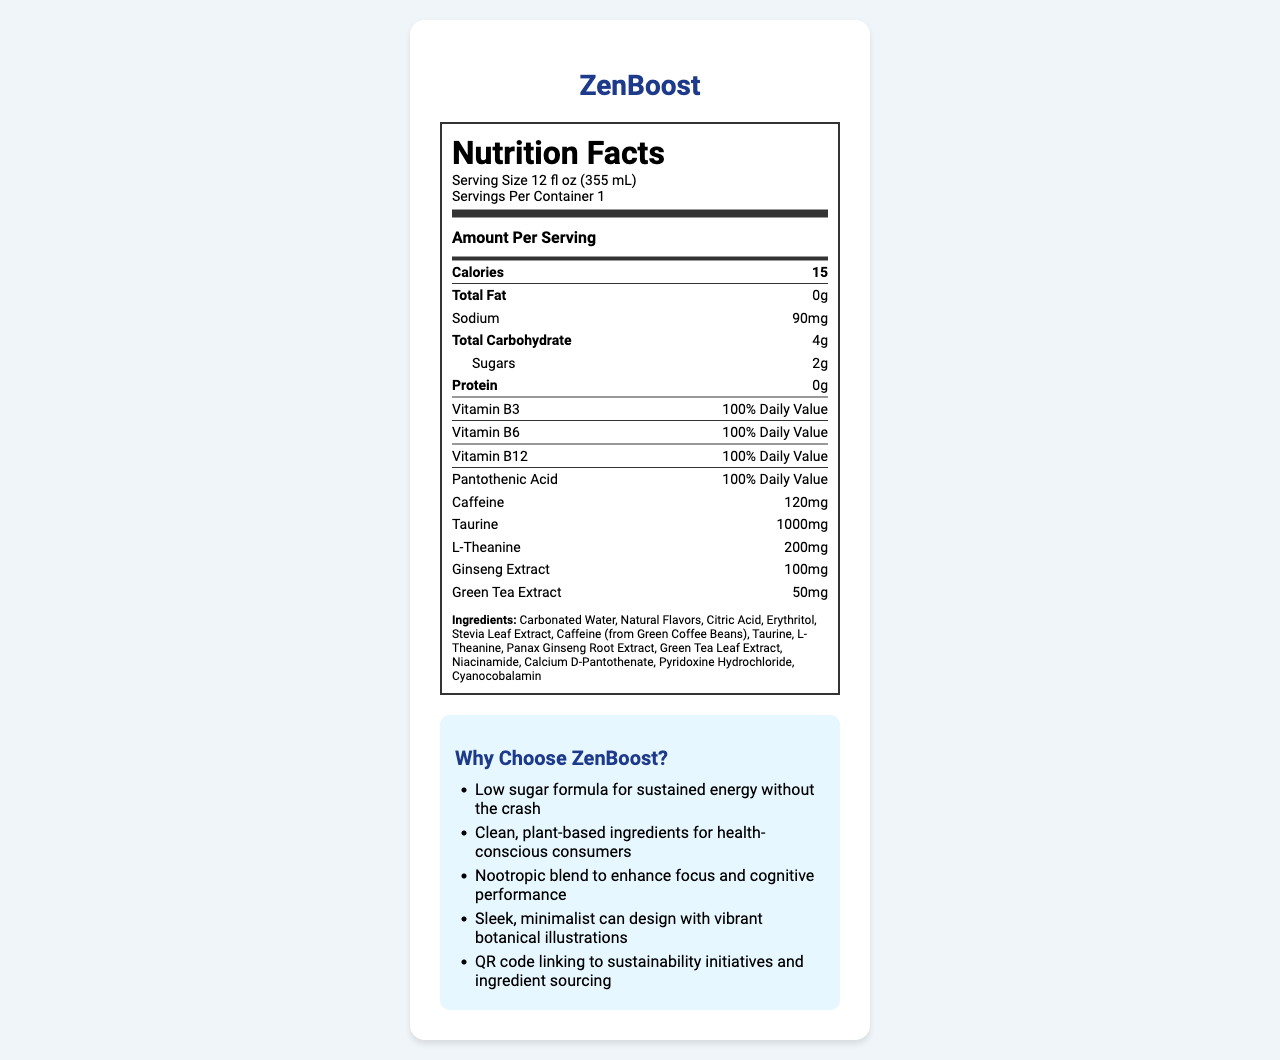What is the serving size of ZenBoost? The serving size is explicitly mentioned at the top of the nutrition facts label.
Answer: 12 fl oz (355 mL) How many calories are in one serving of ZenBoost? The calories per serving are listed in the "Amount Per Serving" section of the nutrition facts label.
Answer: 15 What is the total carbohydrate content in ZenBoost? The total carbohydrate content is specified under the nutrient rows in the nutrition facts label.
Answer: 4g How much caffeine does ZenBoost contain per serving? The caffeine content per serving is listed in the nutrient rows section.
Answer: 120mg Name two ingredients found in ZenBoost. The ingredients are listed towards the bottom section of the nutrition facts label.
Answer: Carbonated Water, Natural Flavors True or False: ZenBoost contains protein. The protein content is listed as 0g in the nutrition facts label.
Answer: False Which of the following vitamins does ZenBoost provide 100% of the Daily Value? A. Vitamin C B. Vitamin B6 C. Vitamin D D. Vitamin B12 Both Vitamin B6 and Vitamin B12 have 100% Daily Value as listed in the vitamin rows section of the nutrition facts label.
Answer: B, D Which distribution channel is mentioned for ZenBoost? A. Walmart B. Target C. Costco D. Sam's Club Target is listed as one of the distribution channels for ZenBoost.
Answer: B Give one marketing point for ZenBoost. One of the marketing points listed is the low sugar formula for sustained energy.
Answer: Low sugar formula for sustained energy without the crash Describe the main idea of the document. The document serves as an informative label detailing the nutritional content, special ingredients, and marketing messages of ZenBoost, targeting health-conscious young adults.
Answer: The document provides detailed nutrition facts, ingredients, and marketing points for ZenBoost, a low-sugar energy drink aimed at health-conscious millennials. It also outlines the vitamins, nootropic ingredients, and distribution channels. What is the purpose of the QR code on the ZenBoost can? The QR code links to information about sustainability initiatives and ingredient sourcing as mentioned in the marketing points section.
Answer: Link to sustainability initiatives and ingredient sourcing Who is the target audience for ZenBoost? The target audience is explicitly mentioned in the document.
Answer: Health-conscious millennials aged 25-38 What is the amount of sugar in ZenBoost? The sugar content is listed under the total carbohydrate section in the nutrition facts.
Answer: 2g How does ZenBoost cater to cognitive performance enhancement? The marketing points indicate that ZenBoost has a nootropic blend, and these ingredients are listed in the nutrient rows.
Answer: It contains a nootropic blend including L-Theanine and Panax Ginseng Root Extract. Which competitor is NOT mentioned in the document? A. Celsius B. GURU Organic Energy C. Monster Energy D. Reign Total Body Fuel Monster Energy is not listed among the key competitors; Celsius, GURU Organic Energy, and Reign Total Body Fuel are.
Answer: C What is the total fat content in ZenBoost? The total fat content is mentioned as 0g in the nutrient rows of the nutrition facts.
Answer: 0g How are the ingredients in ZenBoost described in the marketing points? The marketing points mention that the drink uses clean, plant-based ingredients.
Answer: Clean, plant-based ingredients for health-conscious consumers What type of content is part of ZenBoost's social media strategy? The social media strategy mentions these different types of content strategies utilized to engage with their audience.
Answer: Influencer partnerships with fitness enthusiasts and wellness bloggers, user-generated content campaigns showcasing ZenBoost in active lifestyles, educational content about the benefits of nootropics and clean energy, behind-the-scenes looks at sustainable ingredient sourcing, interactive Instagram polls and quizzes about health and productivity What are the percentages of Daily Value for protein in ZenBoost? The nutrition facts do not provide any percentages of Daily Value for protein. The content is listed as 0g without any percentage.
Answer: Cannot be determined 